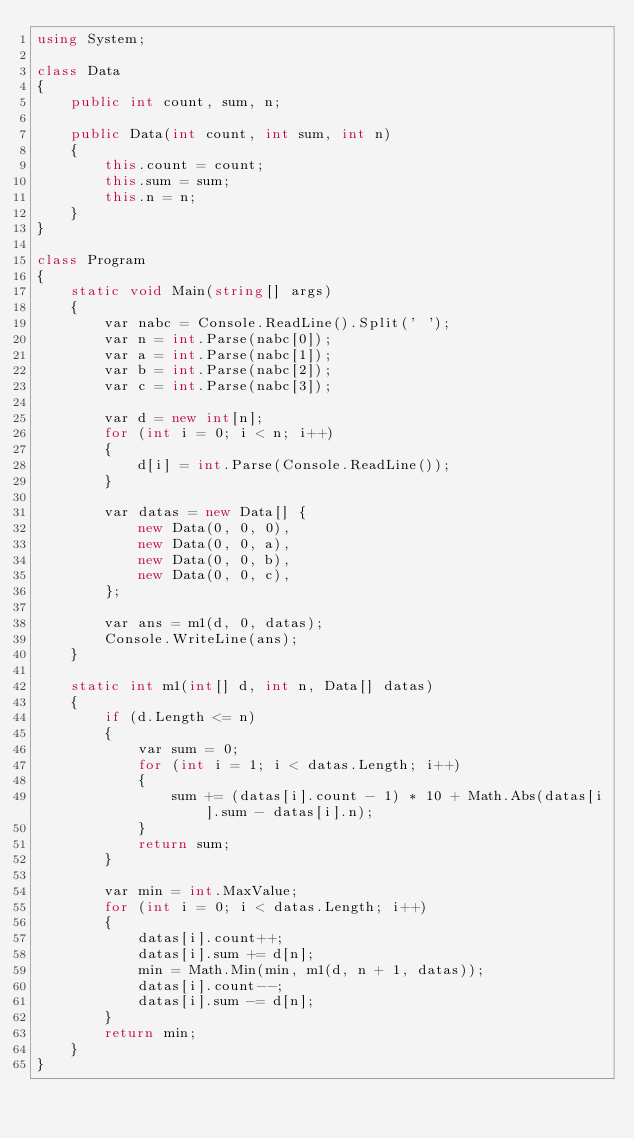Convert code to text. <code><loc_0><loc_0><loc_500><loc_500><_C#_>using System;

class Data
{
    public int count, sum, n;

    public Data(int count, int sum, int n)
    {
        this.count = count;
        this.sum = sum;
        this.n = n;
    }
}

class Program
{
    static void Main(string[] args)
    {
        var nabc = Console.ReadLine().Split(' ');
        var n = int.Parse(nabc[0]);
        var a = int.Parse(nabc[1]);
        var b = int.Parse(nabc[2]);
        var c = int.Parse(nabc[3]);

        var d = new int[n];
        for (int i = 0; i < n; i++)
        {
            d[i] = int.Parse(Console.ReadLine());
        }

        var datas = new Data[] {
            new Data(0, 0, 0),
            new Data(0, 0, a),
            new Data(0, 0, b),
            new Data(0, 0, c),
        };

        var ans = m1(d, 0, datas);
        Console.WriteLine(ans);
    }

    static int m1(int[] d, int n, Data[] datas)
    {
        if (d.Length <= n)
        {
            var sum = 0;
            for (int i = 1; i < datas.Length; i++)
            {
                sum += (datas[i].count - 1) * 10 + Math.Abs(datas[i].sum - datas[i].n);
            }
            return sum;
        }

        var min = int.MaxValue;
        for (int i = 0; i < datas.Length; i++)
        {
            datas[i].count++;
            datas[i].sum += d[n];
            min = Math.Min(min, m1(d, n + 1, datas));
            datas[i].count--;
            datas[i].sum -= d[n];
        }
        return min;
    }
}</code> 